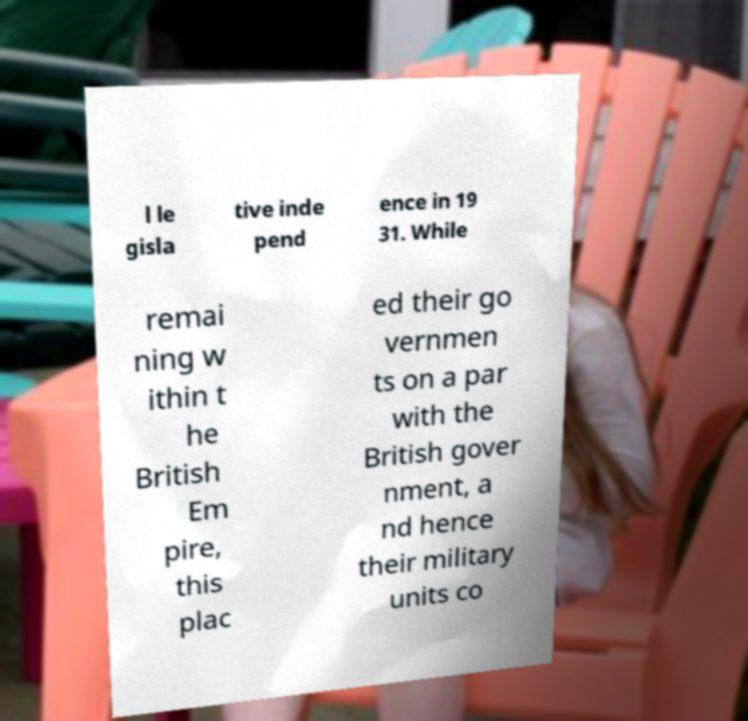Please read and relay the text visible in this image. What does it say? l le gisla tive inde pend ence in 19 31. While remai ning w ithin t he British Em pire, this plac ed their go vernmen ts on a par with the British gover nment, a nd hence their military units co 